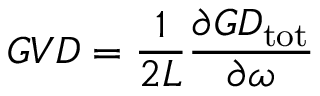Convert formula to latex. <formula><loc_0><loc_0><loc_500><loc_500>G V D = \frac { 1 } { 2 L } \frac { \partial G D _ { t o t } } { \partial \omega }</formula> 